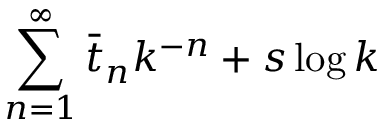Convert formula to latex. <formula><loc_0><loc_0><loc_500><loc_500>\sum _ { n = 1 } ^ { \infty } \bar { t } _ { n } k ^ { - n } + s \log k</formula> 